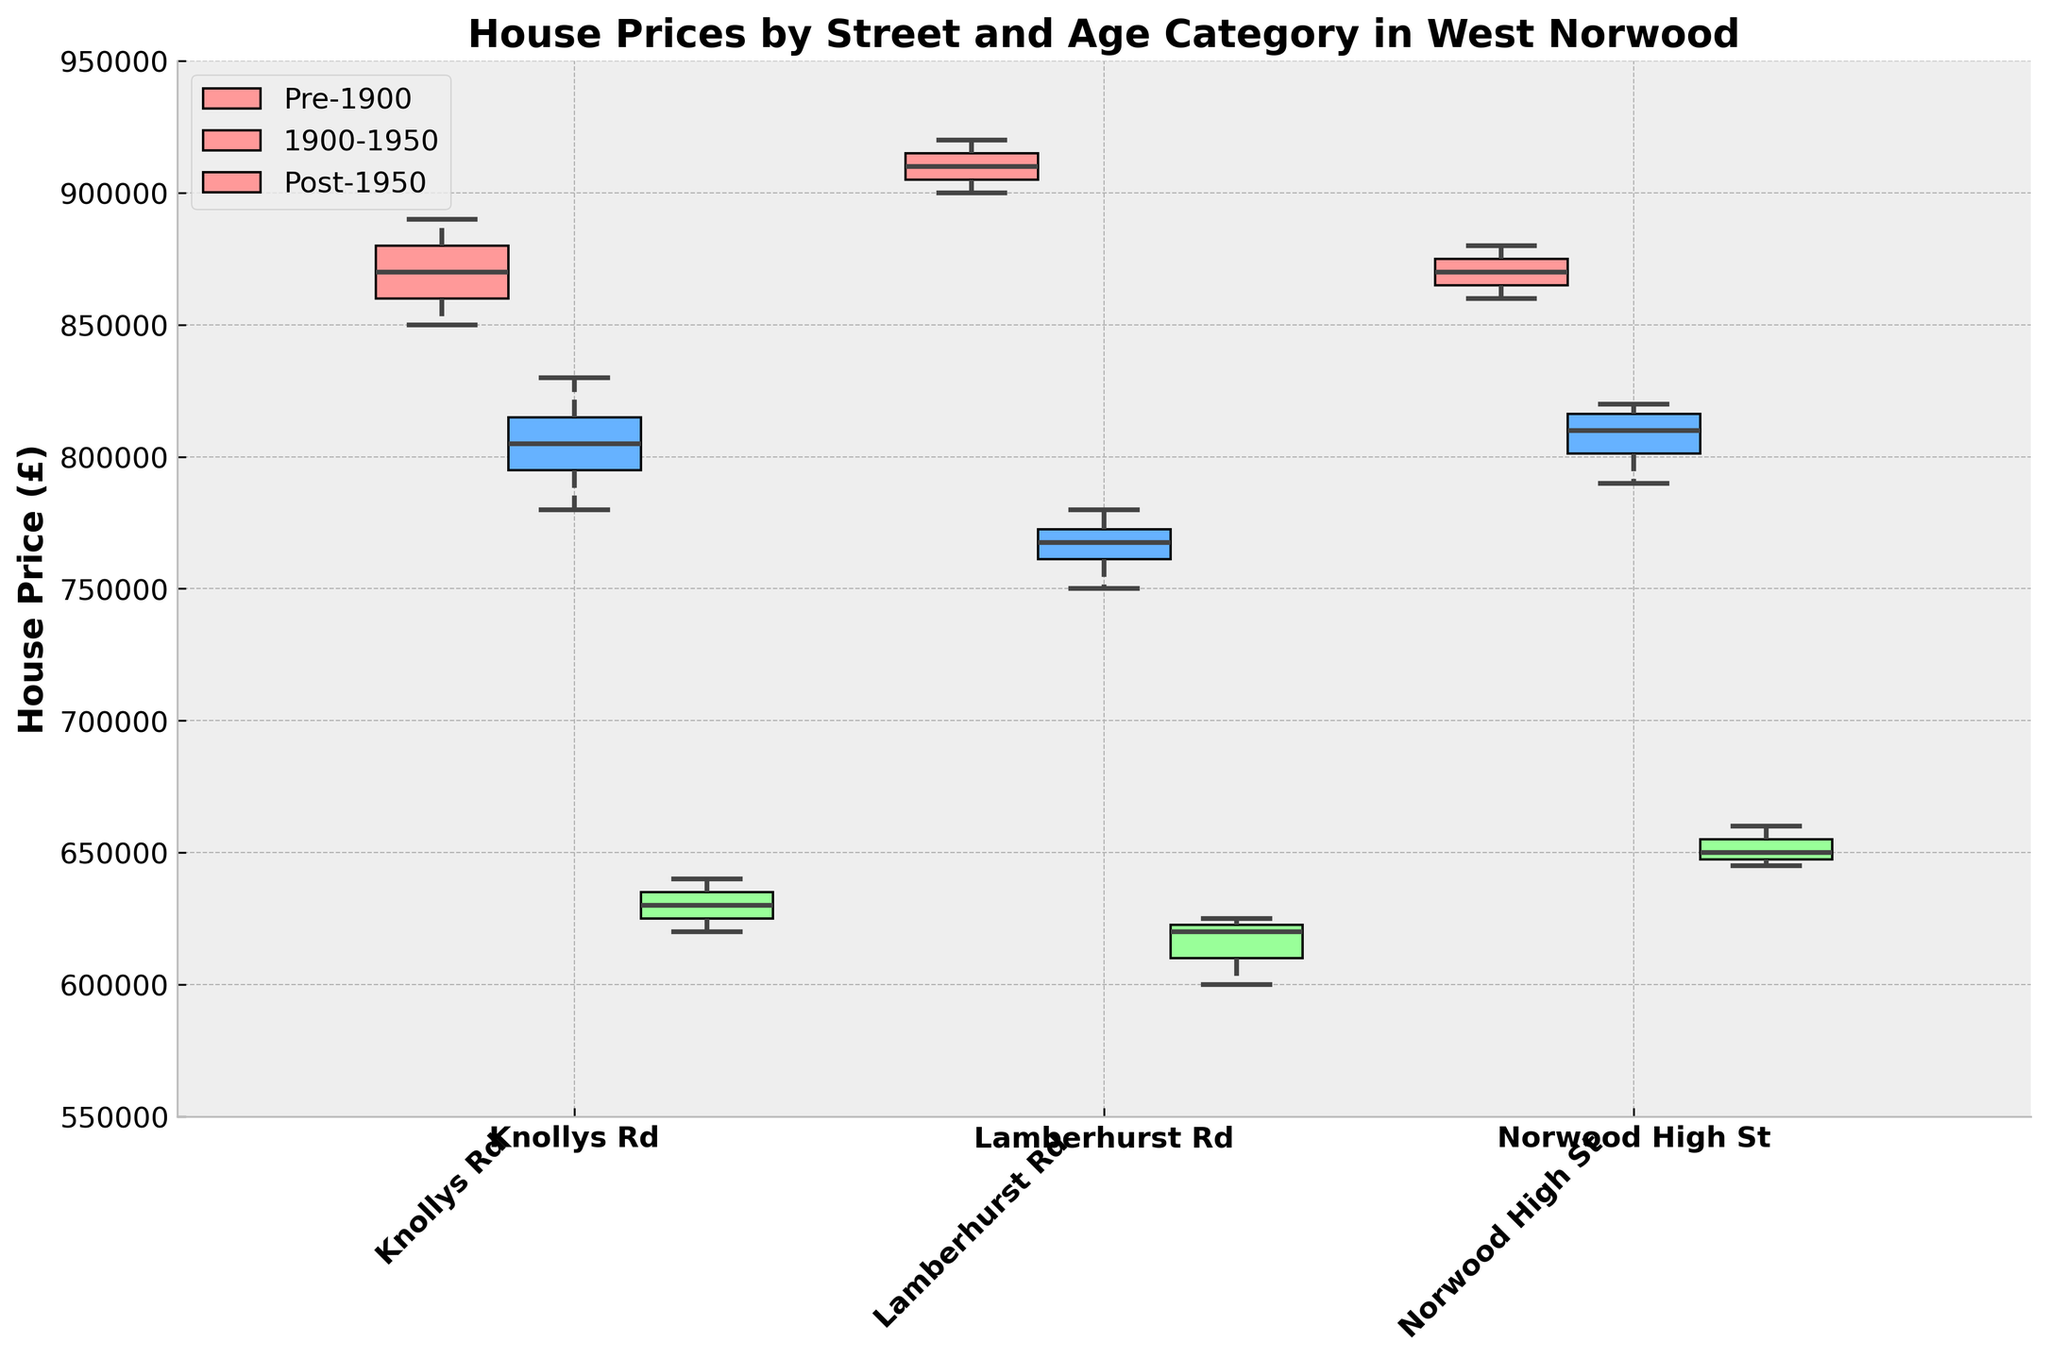What's the title of the figure? The title is usually at the top of the figure and it summarizes what the figure is about. The title of this figure is "House Prices by Street and Age Category in West Norwood."
Answer: House Prices by Street and Age Category in West Norwood What are the names of the streets shown in the figure? The streets can be identified by looking at the x-axis labels. The three streets shown are Knollys Rd, Lamberhurst Rd, and Norwood High St.
Answer: Knollys Rd, Lamberhurst Rd, Norwood High St How does the median house price for Pre-1900 houses on Knollys Rd compare to that on Norwood High St? Locate the median line within the box plots for Pre-1900 houses on both Knollys Rd and Norwood High St. On Knollys Rd, the median is slightly below £870,000, while on Norwood High St, the median is around £870,000.
Answer: Almost the same Which street has the most expensive Post-1950 houses by median price? Find the median lines within the box plots for Post-1950 houses on each street. The median price is highest for Post-1950 houses on Norwood High St, around £650,000.
Answer: Norwood High St Which age category of houses tends to have higher prices on Lamberhurst Rd? Compare the median lines for each age category on Lamberhurst Rd. Pre-1900 houses have the highest median price, around £910,000.
Answer: Pre-1900 What is the approximate price range of 1900-1950 houses on Norwood High St? Examine the whiskers (the dashed lines extending from the boxes) for the 1900-1950 age category on Norwood High St. The range is approximately from £790,000 to £820,000.
Answer: £790,000 to £820,000 Which age category shows the greatest variability in house prices on Knollys Rd? The variability is indicated by the length of the boxes and whiskers. For Knollys Rd, the Post-1950 houses show the greatest variability, with a wide range.
Answer: Post-1950 On which street are the house prices for 1900-1950 houses the closest together, indicating less variability? Look for the shortest boxes and whiskers in the 1900-1950 category. On Lamberhurst Rd, the prices are closest together, indicating less variability.
Answer: Lamberhurst Rd How do house prices for 1900-1950 houses on Knollys Rd compare to Pre-1900 houses on the same street? Compare the median lines for both categories on Knollys Rd. The median for 1900-1950 houses is around £810,000, while for Pre-1900 houses it's around £870,000, indicating that Pre-1900 houses are more expensive.
Answer: Pre-1900 houses are more expensive 